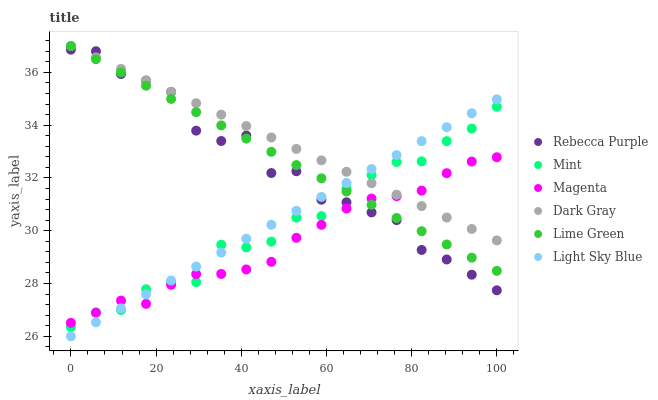Does Magenta have the minimum area under the curve?
Answer yes or no. Yes. Does Dark Gray have the maximum area under the curve?
Answer yes or no. Yes. Does Light Sky Blue have the minimum area under the curve?
Answer yes or no. No. Does Light Sky Blue have the maximum area under the curve?
Answer yes or no. No. Is Lime Green the smoothest?
Answer yes or no. Yes. Is Rebecca Purple the roughest?
Answer yes or no. Yes. Is Dark Gray the smoothest?
Answer yes or no. No. Is Dark Gray the roughest?
Answer yes or no. No. Does Light Sky Blue have the lowest value?
Answer yes or no. Yes. Does Dark Gray have the lowest value?
Answer yes or no. No. Does Lime Green have the highest value?
Answer yes or no. Yes. Does Light Sky Blue have the highest value?
Answer yes or no. No. Does Dark Gray intersect Mint?
Answer yes or no. Yes. Is Dark Gray less than Mint?
Answer yes or no. No. Is Dark Gray greater than Mint?
Answer yes or no. No. 